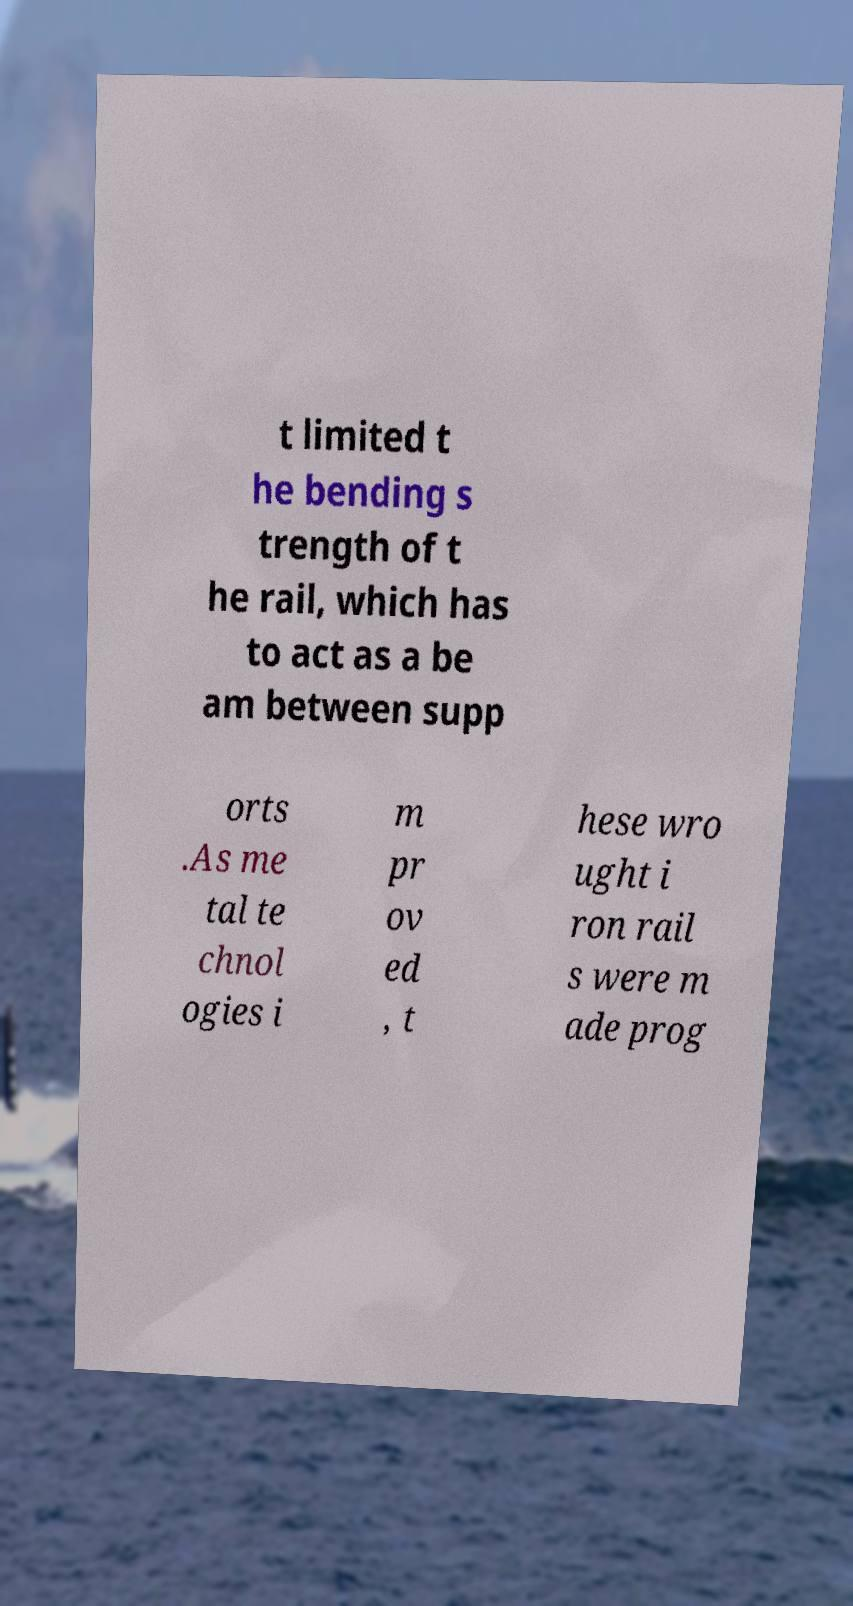Can you read and provide the text displayed in the image?This photo seems to have some interesting text. Can you extract and type it out for me? t limited t he bending s trength of t he rail, which has to act as a be am between supp orts .As me tal te chnol ogies i m pr ov ed , t hese wro ught i ron rail s were m ade prog 